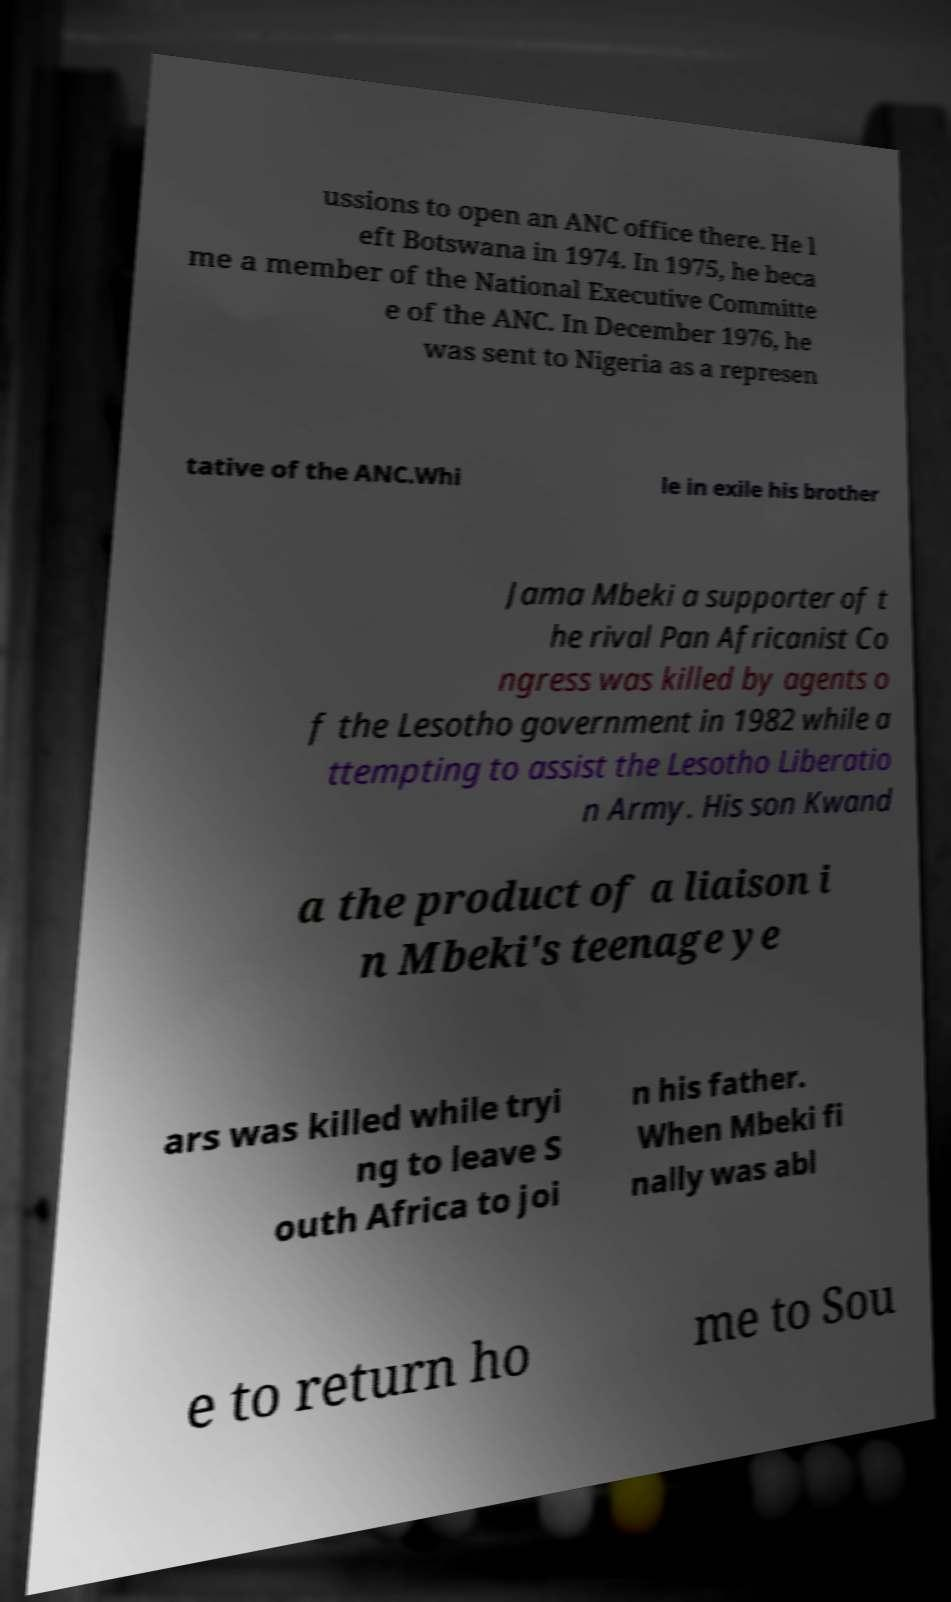I need the written content from this picture converted into text. Can you do that? ussions to open an ANC office there. He l eft Botswana in 1974. In 1975, he beca me a member of the National Executive Committe e of the ANC. In December 1976, he was sent to Nigeria as a represen tative of the ANC.Whi le in exile his brother Jama Mbeki a supporter of t he rival Pan Africanist Co ngress was killed by agents o f the Lesotho government in 1982 while a ttempting to assist the Lesotho Liberatio n Army. His son Kwand a the product of a liaison i n Mbeki's teenage ye ars was killed while tryi ng to leave S outh Africa to joi n his father. When Mbeki fi nally was abl e to return ho me to Sou 